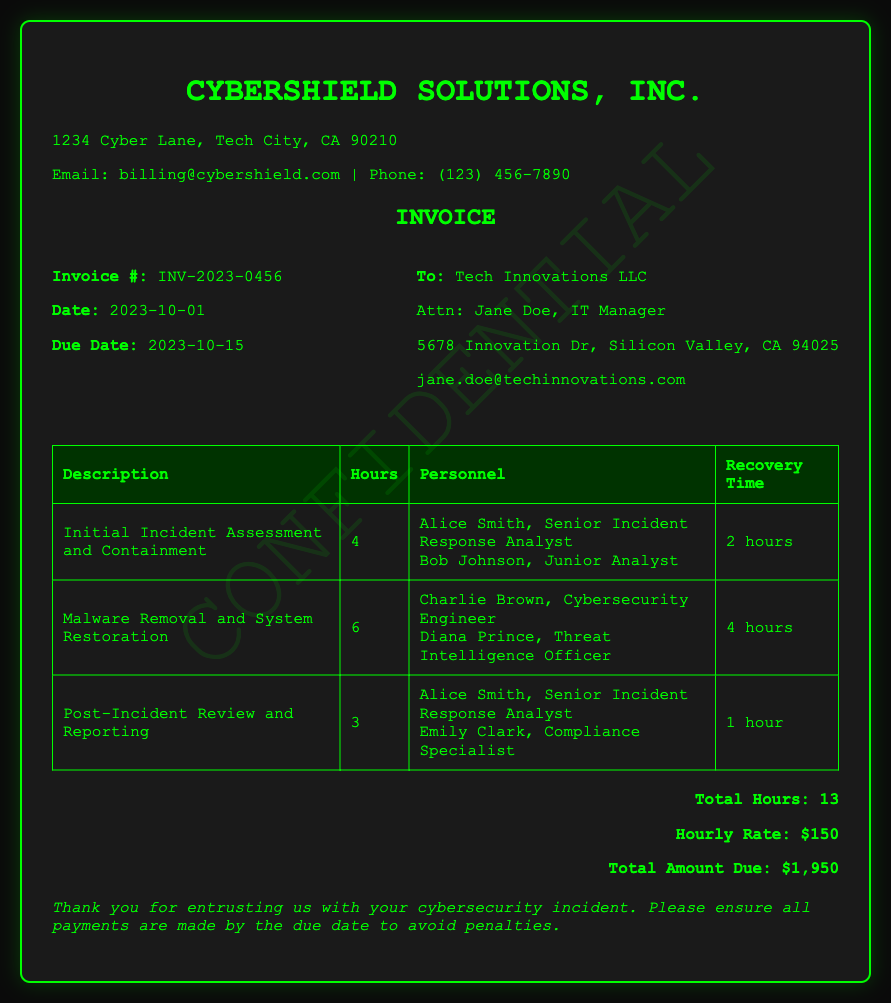What is the invoice number? The invoice number is prominently displayed in the document as the identifier for the billing record.
Answer: INV-2023-0456 Who are the personnel involved in the initial incident assessment? The document lists the personnel responsible for the incident assessment along with their titles under the relevant service.
Answer: Alice Smith, Senior Incident Response Analyst; Bob Johnson, Junior Analyst What is the total amount due? The total amount due is calculated based on the services provided, as indicated at the end of the billing details.
Answer: $1,950 How many hours were spent on malware removal and system restoration? The document specifies the hours allocated to this particular service in the table of services rendered.
Answer: 6 What is the recovery time for the post-incident review? The recovery time is detailed in the table for each service, showing how long it took to complete the task.
Answer: 1 hour What was the hourly rate for the services provided? The hourly rate is mentioned in the total calculation section of the invoice document.
Answer: $150 How many total hours were billed? The total hours billed is summarized at the bottom of the services rendered section in the invoice.
Answer: 13 Who is the attention person for the billing? The document identifies the contact person for the billing correspondence under the client details section.
Answer: Jane Doe, IT Manager 